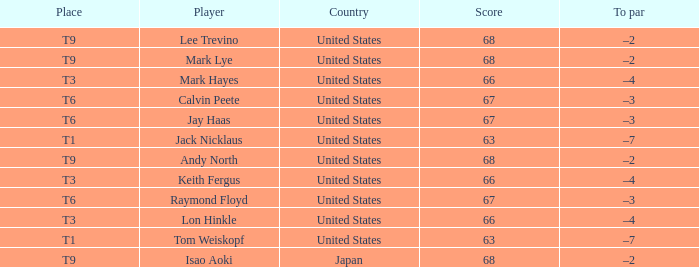What is the Country, when Place is T6, and when Player is "Raymond Floyd"? United States. 